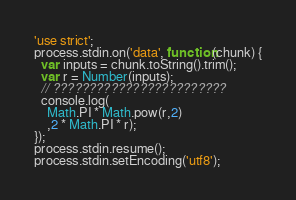<code> <loc_0><loc_0><loc_500><loc_500><_JavaScript_>'use strict';
process.stdin.on('data', function(chunk) {
  var inputs = chunk.toString().trim();
  var r = Number(inputs);
  // ????????????????????????
  console.log(
  	Math.PI * Math.pow(r,2)
  	,2 * Math.PI * r);
});
process.stdin.resume();
process.stdin.setEncoding('utf8');</code> 